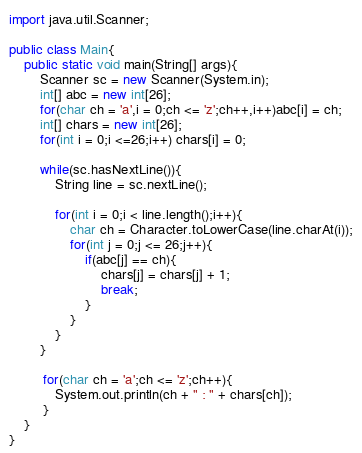Convert code to text. <code><loc_0><loc_0><loc_500><loc_500><_Java_>import java.util.Scanner;

public class Main{
	public static void main(String[] args){
		Scanner sc = new Scanner(System.in);
		int[] abc = new int[26];
		for(char ch = 'a',i = 0;ch <= 'z';ch++,i++)abc[i] = ch;
		int[] chars = new int[26];
		for(int i = 0;i <=26;i++) chars[i] = 0;

		while(sc.hasNextLine()){
			String line = sc.nextLine();

			for(int i = 0;i < line.length();i++){
				char ch = Character.toLowerCase(line.charAt(i));
				for(int j = 0;j <= 26;j++){
					if(abc[j] == ch){
						chars[j] = chars[j] + 1;
						break;
					}
				}
			}
		}

		 for(char ch = 'a';ch <= 'z';ch++){
		 	System.out.println(ch + " : " + chars[ch]);
		 }
	}
}</code> 